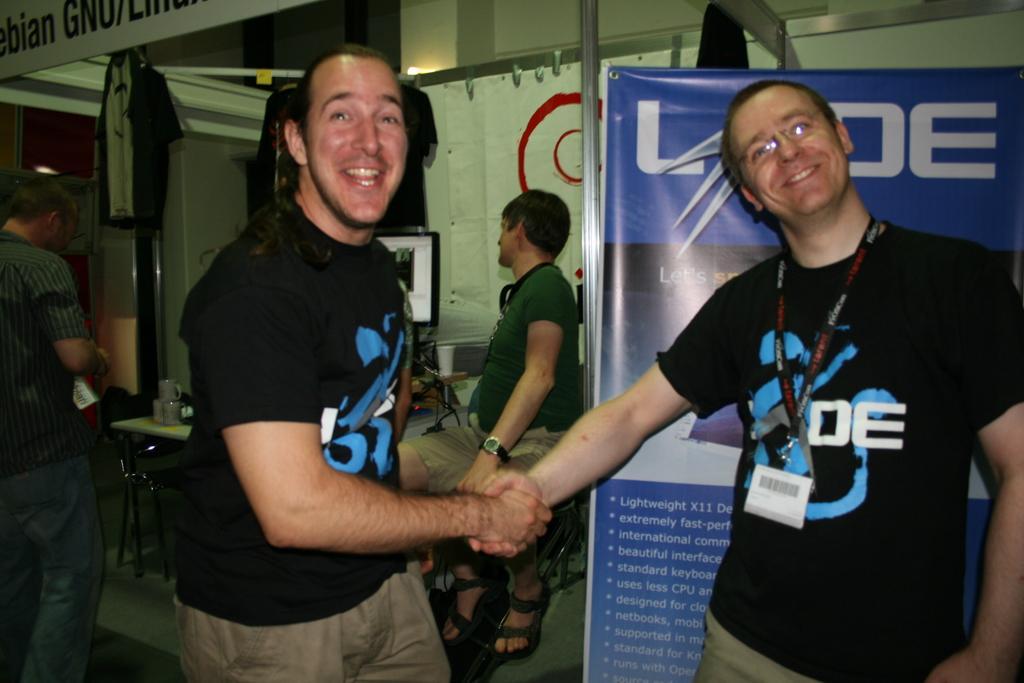Please provide a concise description of this image. In this picture we can see four men where three are standing on the floor and a man sitting on a chair, cups, glass, monitor, banner and in the background we can see rods, cloth. 